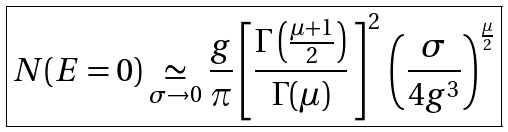<formula> <loc_0><loc_0><loc_500><loc_500>\boxed { N ( E = 0 ) \underset { \sigma \to 0 } { \simeq } \frac { g } \pi \left [ \frac { \Gamma \left ( \frac { \mu + 1 } { 2 } \right ) } { \Gamma ( \mu ) } \, \right ] ^ { 2 } \, \left ( \frac { \sigma } { 4 g ^ { 3 } } \right ) ^ { \frac { \mu } { 2 } } }</formula> 